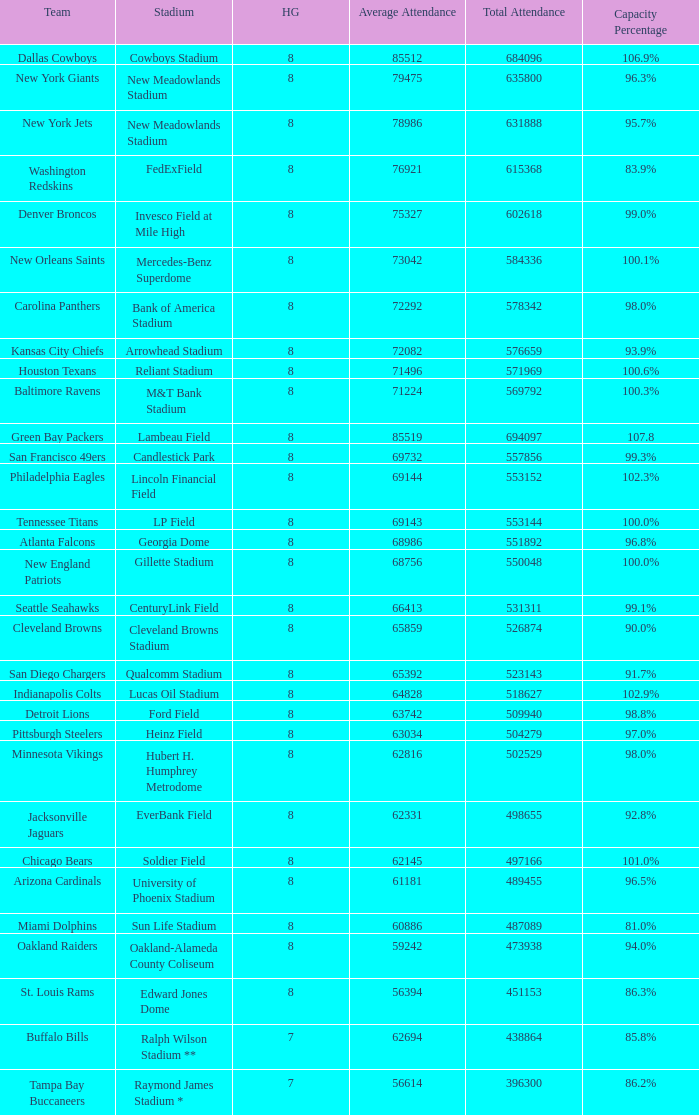How many average attendance has a capacity percentage of 96.5% 1.0. 